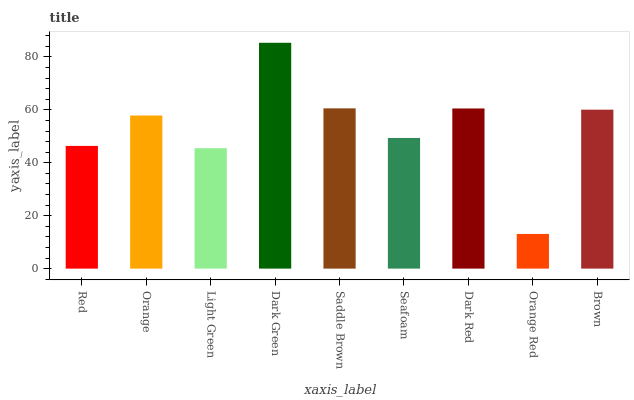Is Orange Red the minimum?
Answer yes or no. Yes. Is Dark Green the maximum?
Answer yes or no. Yes. Is Orange the minimum?
Answer yes or no. No. Is Orange the maximum?
Answer yes or no. No. Is Orange greater than Red?
Answer yes or no. Yes. Is Red less than Orange?
Answer yes or no. Yes. Is Red greater than Orange?
Answer yes or no. No. Is Orange less than Red?
Answer yes or no. No. Is Orange the high median?
Answer yes or no. Yes. Is Orange the low median?
Answer yes or no. Yes. Is Orange Red the high median?
Answer yes or no. No. Is Light Green the low median?
Answer yes or no. No. 